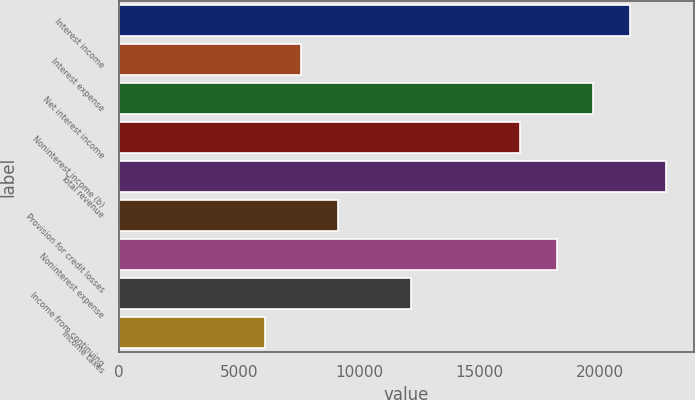<chart> <loc_0><loc_0><loc_500><loc_500><bar_chart><fcel>Interest income<fcel>Interest expense<fcel>Net interest income<fcel>Noninterest income (b)<fcel>Total revenue<fcel>Provision for credit losses<fcel>Noninterest expense<fcel>Income from continuing<fcel>Income taxes<nl><fcel>21246.2<fcel>7588.2<fcel>19728.7<fcel>16693.6<fcel>22763.8<fcel>9105.76<fcel>18211.1<fcel>12140.9<fcel>6070.64<nl></chart> 